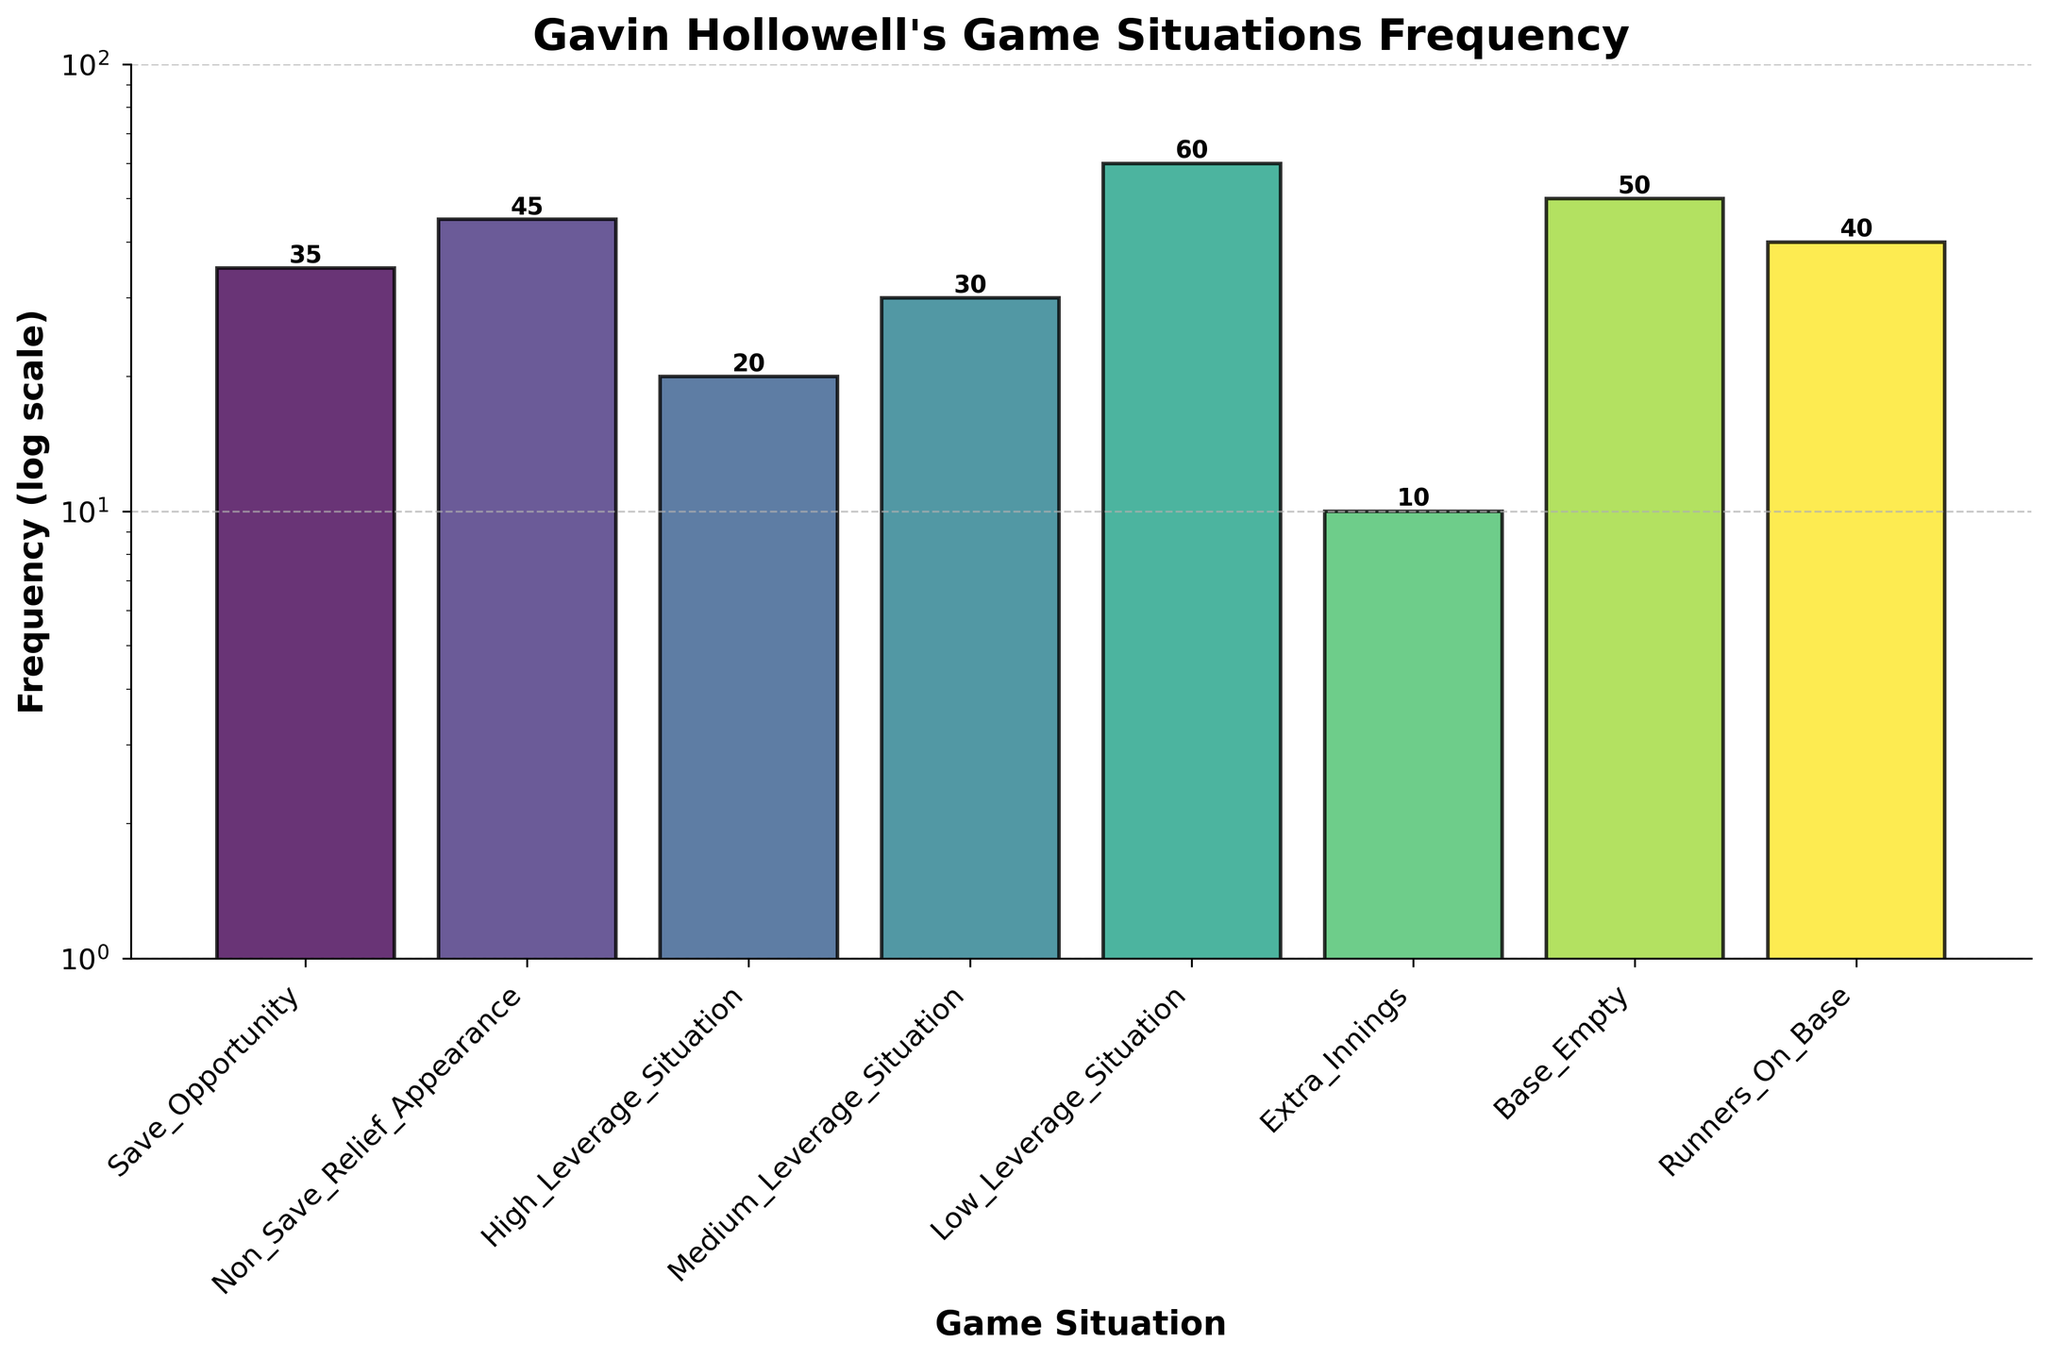What is the title of the plot? The title is directly written at the top of the plot. It reads "Gavin Hollowell's Game Situations Frequency".
Answer: Gavin Hollowell's Game Situations Frequency How many different game situations are shown in the figure? By counting the x-axis labels, there are 8 different game situations listed.
Answer: 8 Which game situation has the lowest frequency? By looking at the bar heights, "Extra Innings" has the lowest bar, indicating a frequency of 10.
Answer: Extra Innings What is the frequency of "High Leverage Situation"? By finding the bar labeled "High Leverage Situation" and reading the height, the frequency is shown to be 20.
Answer: 20 What is the frequency difference between "Base Empty" and "Runners On Base"? The frequency for "Base Empty" is 50 and for "Runners On Base" is 40. The difference is 50 - 40.
Answer: 10 Which game situation has the highest frequency and what is it? The tallest bar represents the highest frequency, which is for "Low Leverage Situation" at 60.
Answer: Low Leverage Situation, 60 Compare the frequency of "Save Opportunity" to "Non-Save Relief Appearance". Which is higher? The bar for "Non-Save Relief Appearance" is taller than the bar for "Save Opportunity". Hence, "Non-Save Relief Appearance" is higher.
Answer: Non-Save Relief Appearance What is the average frequency of all the game situations? Summing all frequencies: 35 + 45 + 20 + 30 + 60 + 10 + 50 + 40 = 290. Dividing by the number of situations: 290 / 8.
Answer: 36.25 In which game situations has Gavin Hollowell appeared at least 30 times? The bars with frequencies equal to or greater than 30 are "Save Opportunity" (35), "Non-Save Relief Appearance" (45), "Medium Leverage Situation" (30), "Low Leverage Situation" (60), "Base Empty" (50), and "Runners On Base" (40).
Answer: Save Opportunity, Non-Save Relief Appearance, Medium Leverage Situation, Low Leverage Situation, Base Empty, Runners On Base Given the log scale, which game situation's frequency appears the greatest relative difference from "Medium Leverage Situation"? On a log scale, the relative difference (ratios) are clearer. "Low Leverage Situation" with a frequency of 60 when compared to "Medium Leverage Situation" at 30 shows the highest relative difference (60/30 = 2).
Answer: Low Leverage Situation 